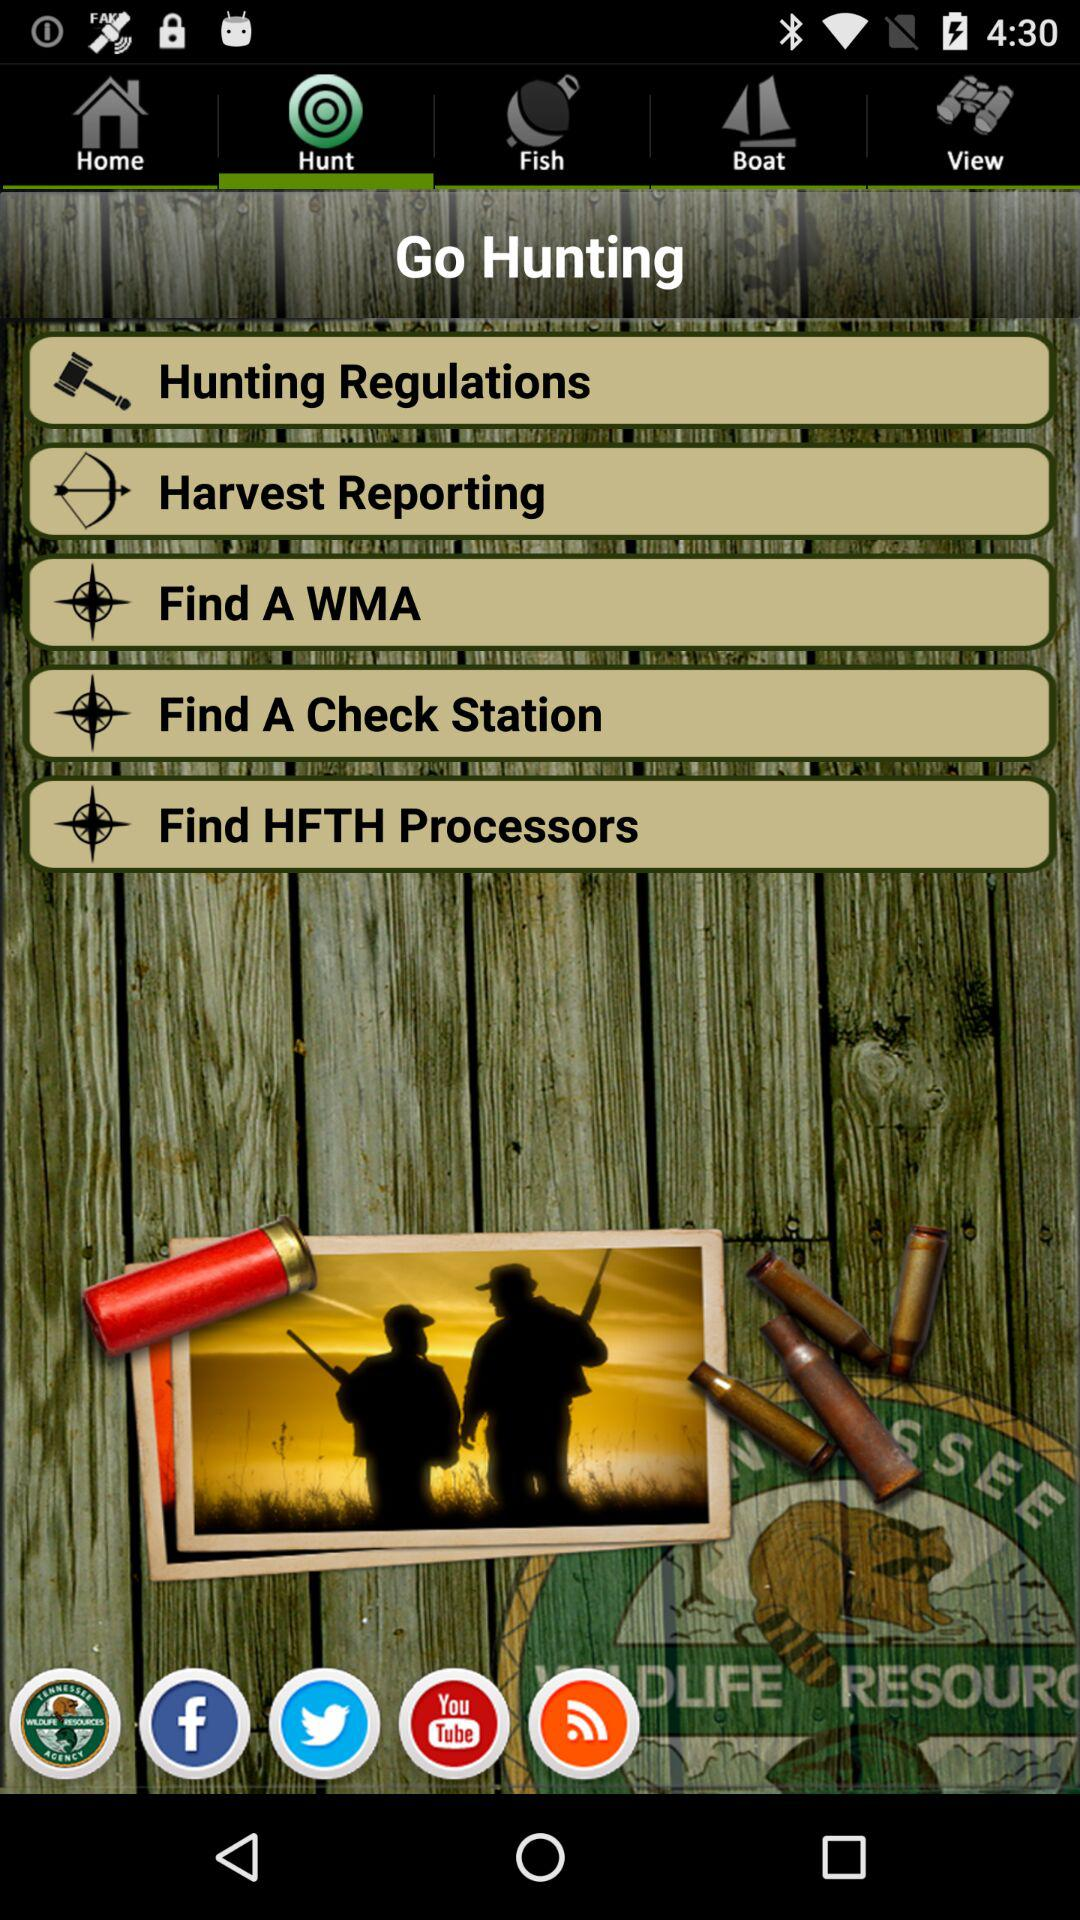Which tab is currently selected? The currently selected tab is "Hunt". 